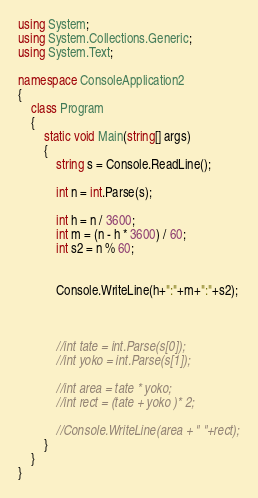<code> <loc_0><loc_0><loc_500><loc_500><_C#_>using System;
using System.Collections.Generic;
using System.Text;

namespace ConsoleApplication2
{
    class Program
    {
        static void Main(string[] args)
        {
            string s = Console.ReadLine();

            int n = int.Parse(s);

            int h = n / 3600;
            int m = (n - h * 3600) / 60;
            int s2 = n % 60;


            Console.WriteLine(h+":"+m+":"+s2);
            


            //int tate = int.Parse(s[0]);
            //int yoko = int.Parse(s[1]);

            //int area = tate * yoko;
            //int rect = (tate + yoko )* 2;

            //Console.WriteLine(area + " "+rect);
        }
    }
}</code> 